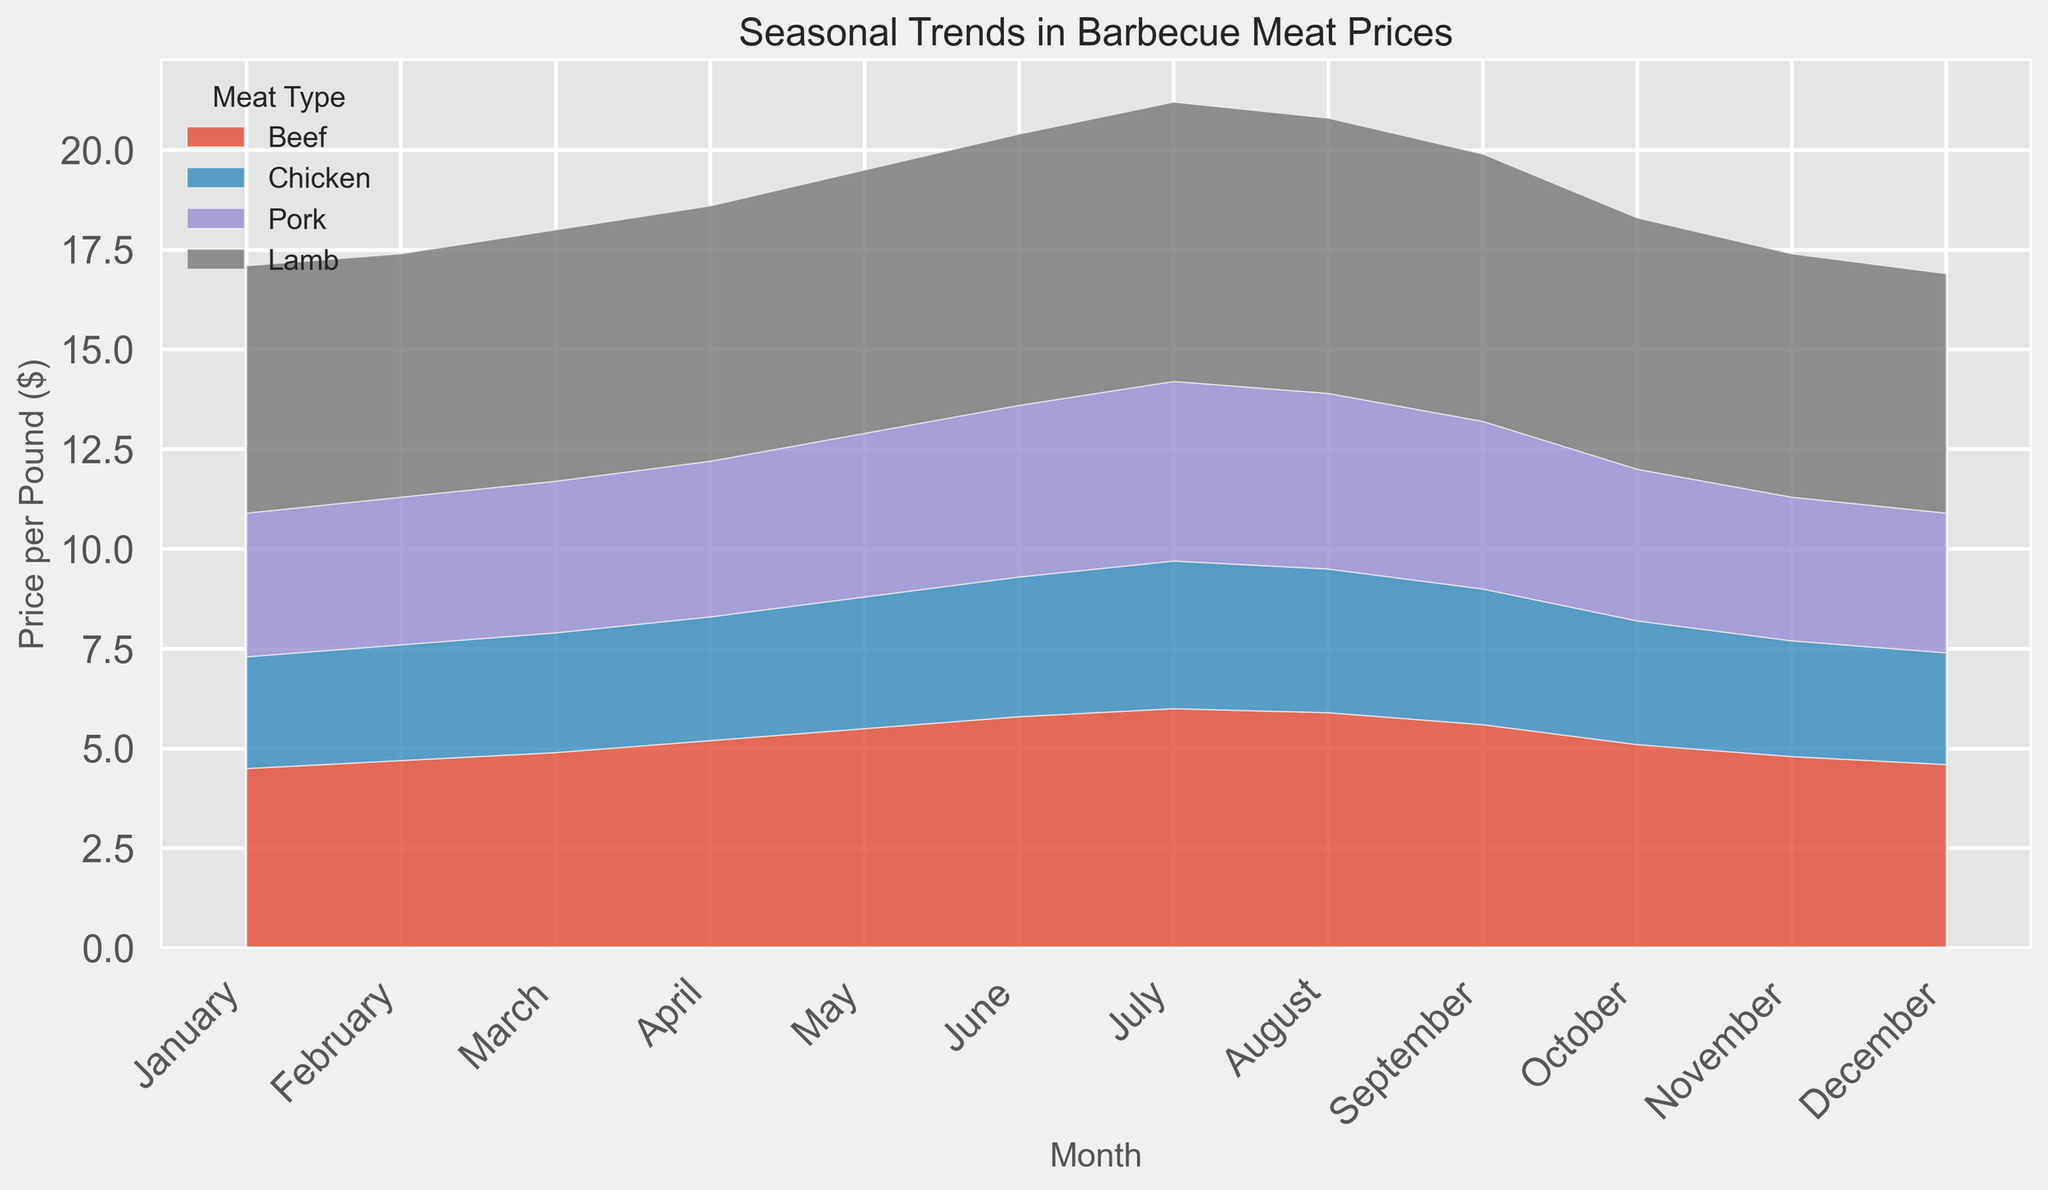What's the peak price of beef throughout the year? Identify the highest point in the area representing beef prices on the chart. This occurs in July.
Answer: 6.0 Which month sees the highest price for chicken? Look at the top of the chicken area (usually represented by color) and find the month where it reaches its highest point, which happens in July.
Answer: July In which month does pork price start increasing and when does it start decreasing? Observe the slope of the pork area. The price starts increasing noticeably from February to July and starts decreasing from August onwards.
Answer: February and August How much does the price of lamb fluctuate between its lowest point and its highest point? Find the highest and lowest points in the lamb area. The highest point is in July (7.0) and the lowest is in December (6.0). Subtract the lowest from the highest: 7.0 - 6.0 = 1.0.
Answer: 1.0 What is the total price for all meats in July? Sum the prices for all meats in July: Beef (6.0), Chicken (3.7), Pork (4.5), Lamb (7.0). The total is 6.0 + 3.7 + 4.5 + 7.0 = 21.2.
Answer: 21.2 During which months is there a price crossover between beef and lamb? Look for points where the beef and lamb areas are level. The crossover occurs between January and February.
Answer: January and February Which meat shows the least fluctuation in price throughout the year? Compare the range of fluctuations for all meats. Chicken shows the least fluctuation, with prices ranging only from 2.8 to 3.7.
Answer: Chicken How does the price trend of pork compare to that of chicken over the year? Compare the visual trend lines for pork and chicken. Both show an increasing trend until mid-year and then a decreasing trend, but pork shows higher fluctuations overall.
Answer: Both show similar trends but pork has more fluctuations 